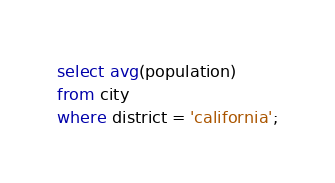Convert code to text. <code><loc_0><loc_0><loc_500><loc_500><_SQL_>select avg(population)
from city
where district = 'california';</code> 